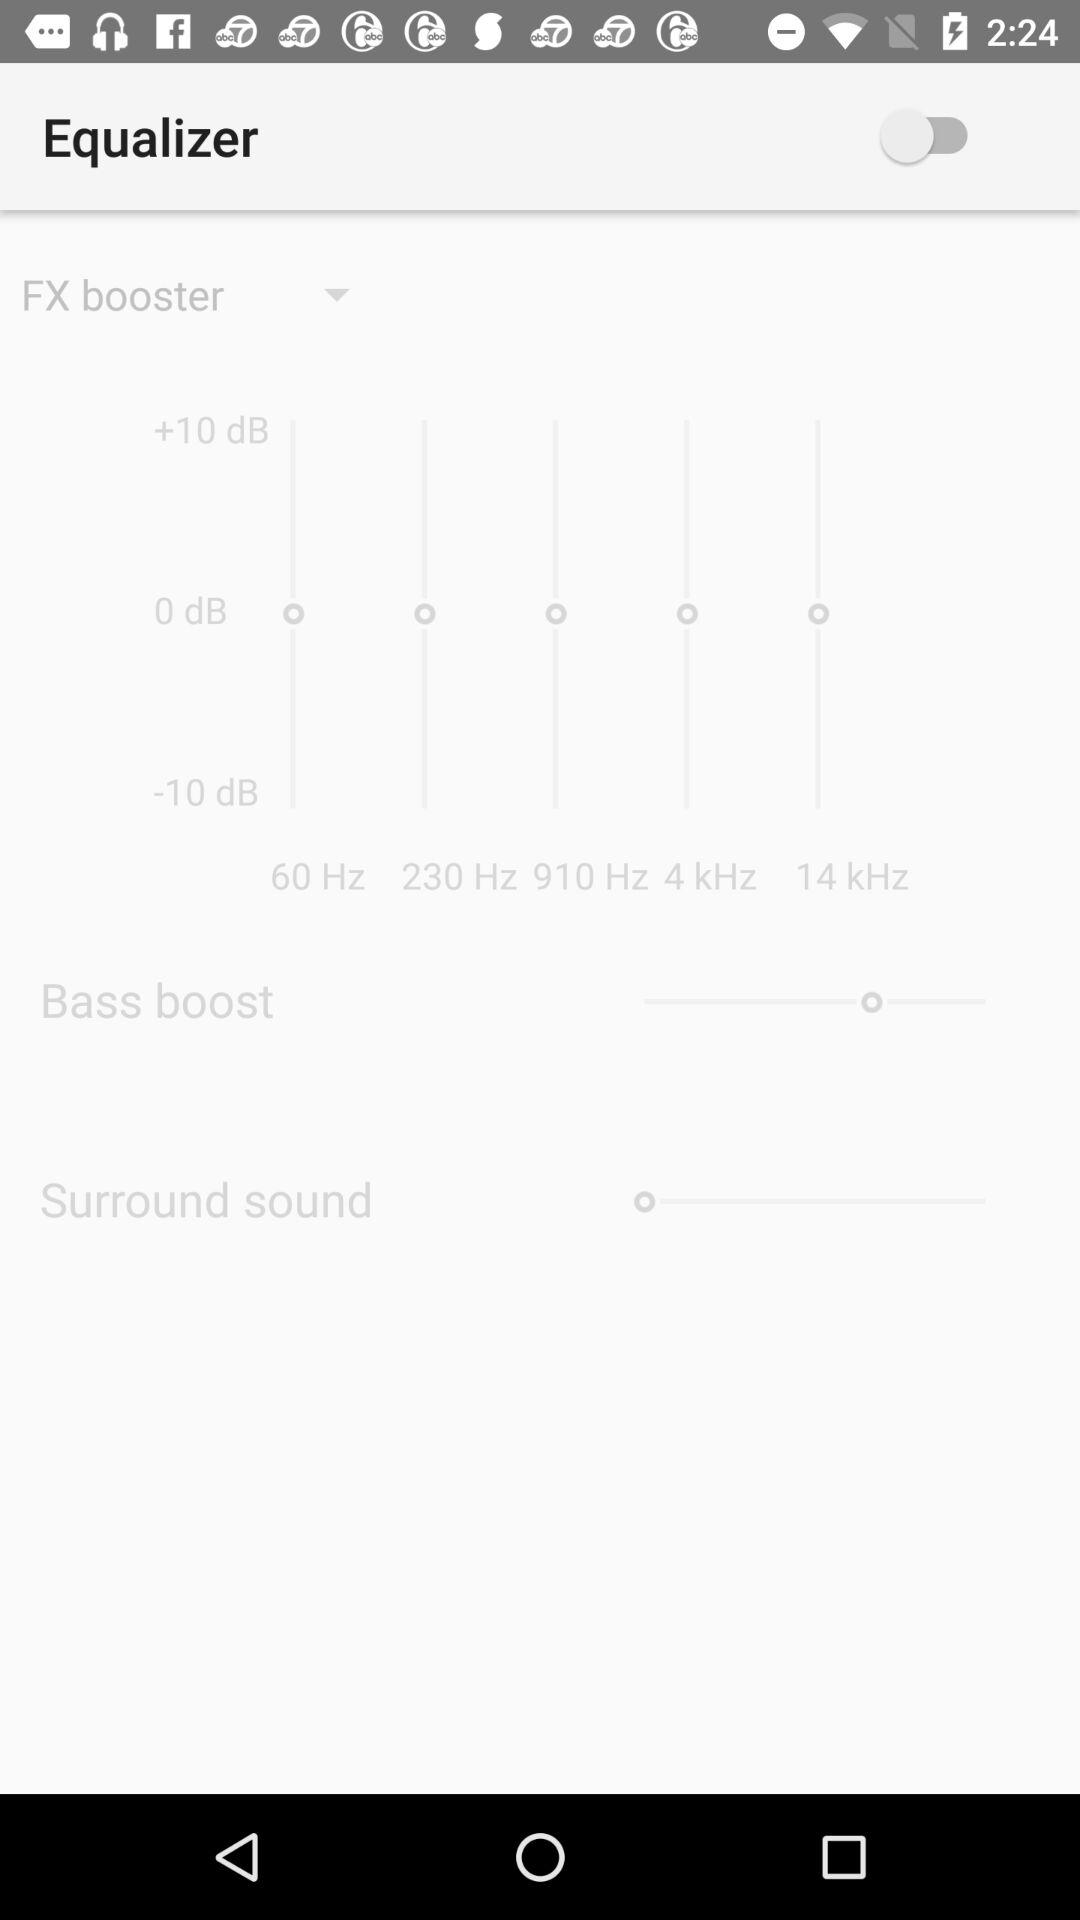How many frequency bands are there in the equalizer?
Answer the question using a single word or phrase. 5 